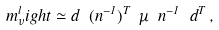Convert formula to latex. <formula><loc_0><loc_0><loc_500><loc_500>m _ { \nu } ^ { l } i g h t \simeq d \ ( n ^ { - 1 } ) ^ { T } \ { \mu } \ n ^ { - 1 } \ d ^ { T } \, ,</formula> 